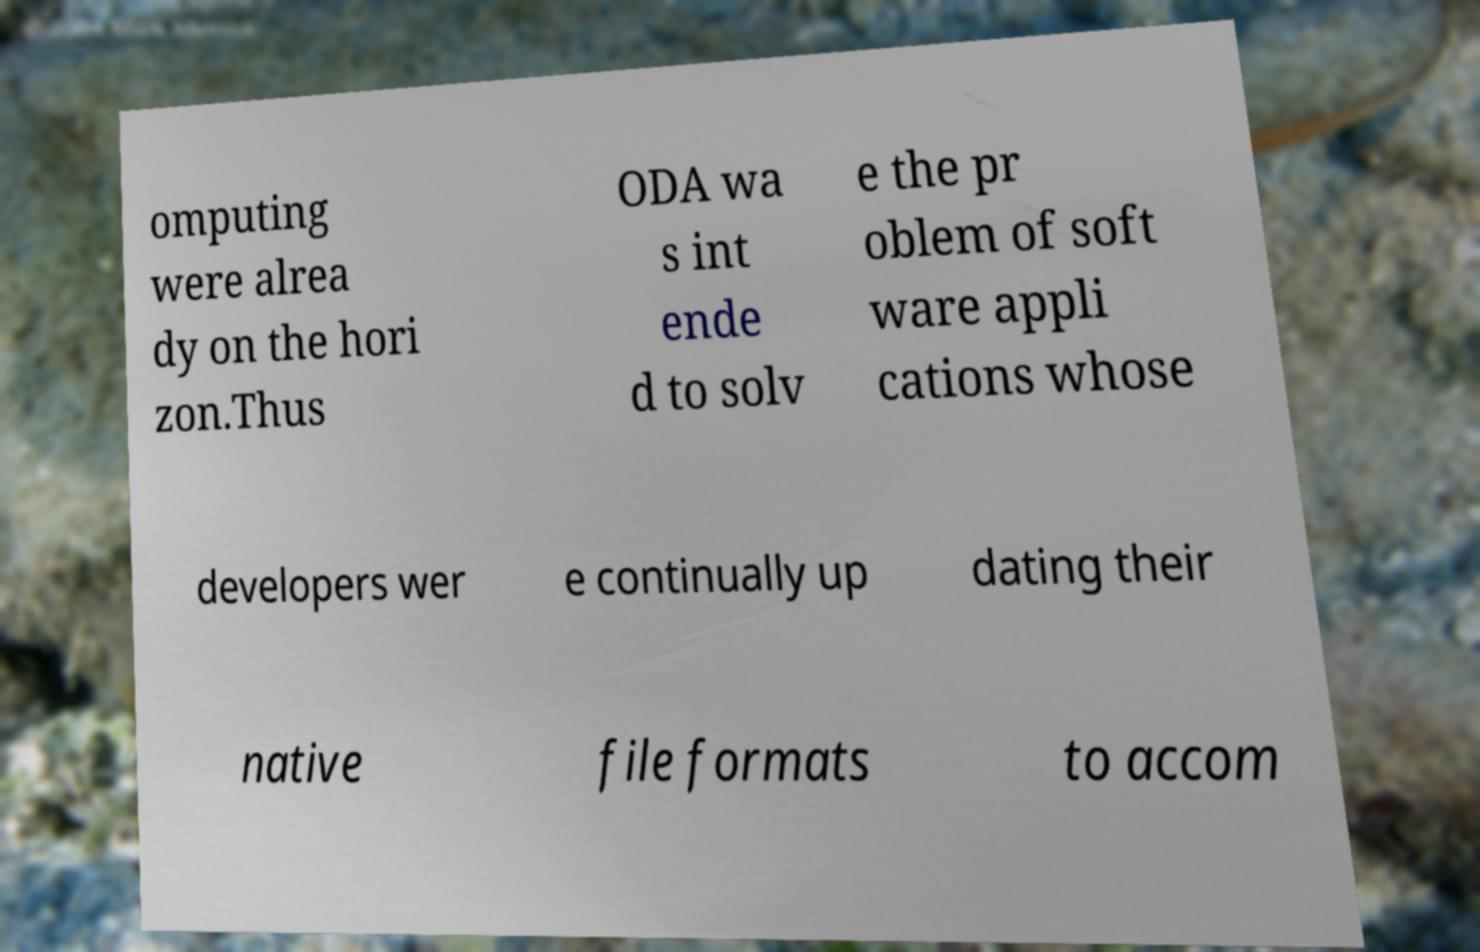Please read and relay the text visible in this image. What does it say? omputing were alrea dy on the hori zon.Thus ODA wa s int ende d to solv e the pr oblem of soft ware appli cations whose developers wer e continually up dating their native file formats to accom 